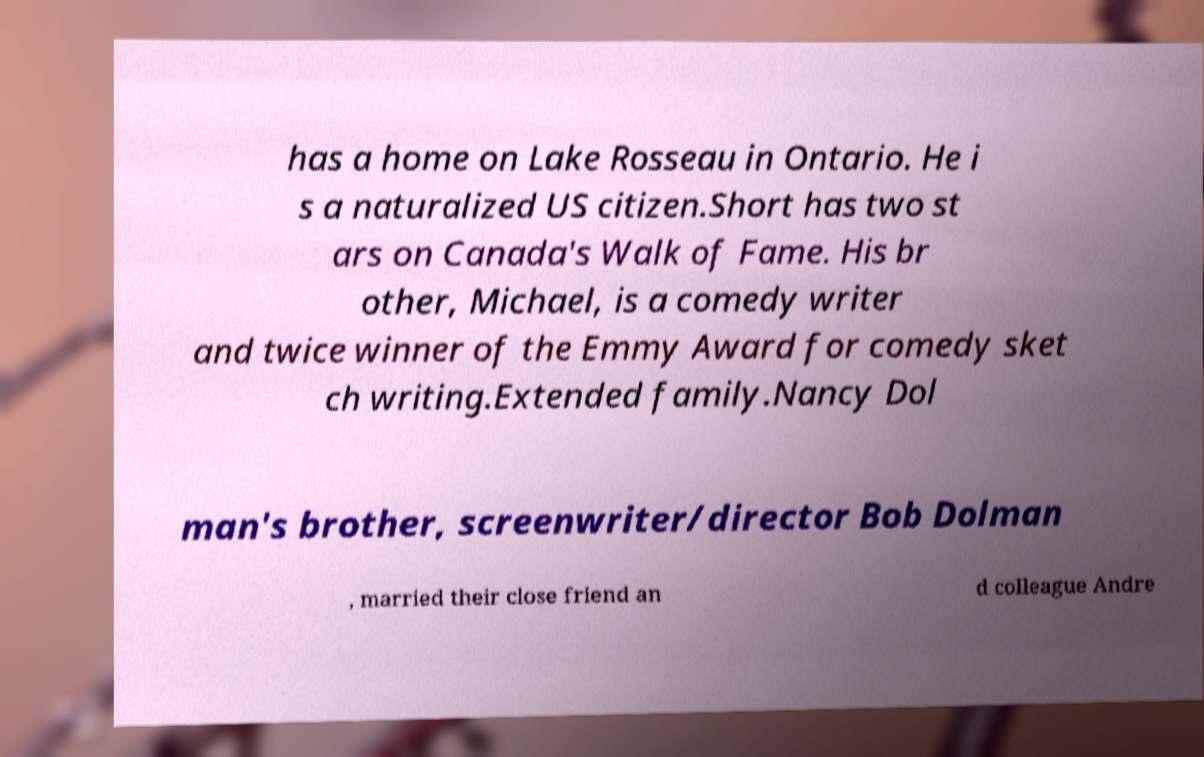Can you read and provide the text displayed in the image?This photo seems to have some interesting text. Can you extract and type it out for me? has a home on Lake Rosseau in Ontario. He i s a naturalized US citizen.Short has two st ars on Canada's Walk of Fame. His br other, Michael, is a comedy writer and twice winner of the Emmy Award for comedy sket ch writing.Extended family.Nancy Dol man's brother, screenwriter/director Bob Dolman , married their close friend an d colleague Andre 